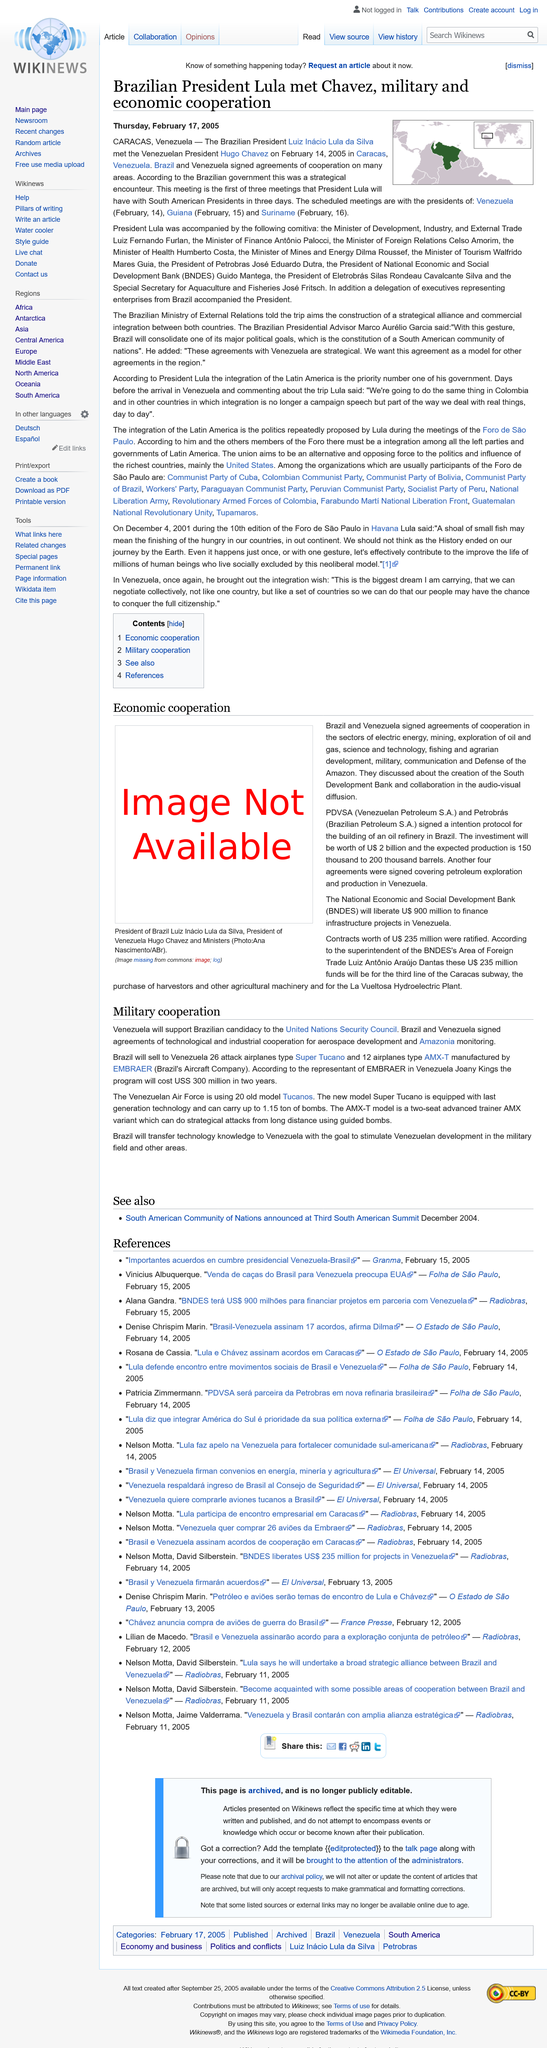Identify some key points in this picture. On February 16th, there will be a scheduled meeting with the president of Suriname. On February 14th, 2005, the Brazilian President and the Venezuelan President met. Brazil has entered into cooperation accords with several countries, including Venezuela. 